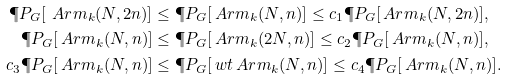Convert formula to latex. <formula><loc_0><loc_0><loc_500><loc_500>\P P _ { G } [ \ A r m _ { k } ( N , 2 n ) ] & \leq \P P _ { G } [ \ A r m _ { k } ( N , n ) ] \leq c _ { 1 } \P P _ { G } [ \ A r m _ { k } ( N , 2 n ) ] , \\ \P P _ { G } [ \ A r m _ { k } ( N , n ) ] & \leq \P P _ { G } [ \ A r m _ { k } ( 2 N , n ) ] \leq c _ { 2 } \P P _ { G } [ \ A r m _ { k } ( N , n ) ] , \\ c _ { 3 } \P P _ { G } [ \ A r m _ { k } ( N , n ) ] & \leq \P P _ { G } [ \ w t { \ A r m } _ { k } ( N , n ) ] \leq c _ { 4 } \P P _ { G } [ \ A r m _ { k } ( N , n ) ] .</formula> 